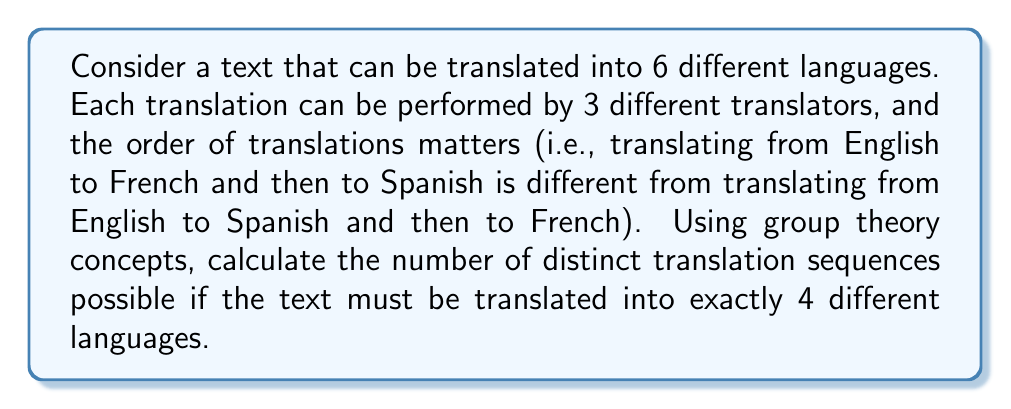Can you solve this math problem? To solve this problem, we can use the concept of permutations with repetition from group theory. Here's a step-by-step explanation:

1) First, we need to choose 4 languages out of the 6 available. This can be done in $\binom{6}{4}$ ways.

2) For each of these language selections, we need to consider the number of ways to arrange the 4 translations. This is a permutation of 4 elements, which is 4!.

3) For each translation, we have 3 possible translators. This introduces an additional factor of $3^4$.

4) Combining these factors, we get:

   $$\binom{6}{4} \cdot 4! \cdot 3^4$$

5) Let's calculate each part:
   
   $\binom{6}{4} = \frac{6!}{4!(6-4)!} = \frac{6 \cdot 5}{2 \cdot 1} = 15$
   
   $4! = 4 \cdot 3 \cdot 2 \cdot 1 = 24$
   
   $3^4 = 81$

6) Multiplying these together:

   $15 \cdot 24 \cdot 81 = 29,160$

Therefore, there are 29,160 distinct translation sequences possible.
Answer: 29,160 distinct translation sequences 